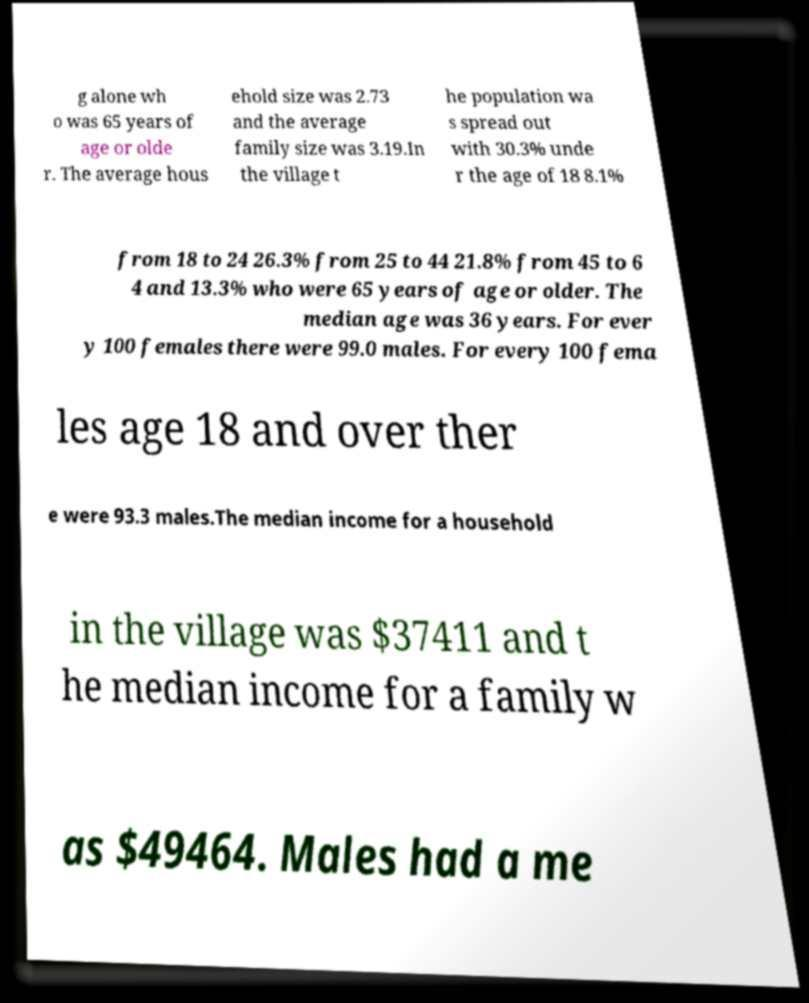I need the written content from this picture converted into text. Can you do that? g alone wh o was 65 years of age or olde r. The average hous ehold size was 2.73 and the average family size was 3.19.In the village t he population wa s spread out with 30.3% unde r the age of 18 8.1% from 18 to 24 26.3% from 25 to 44 21.8% from 45 to 6 4 and 13.3% who were 65 years of age or older. The median age was 36 years. For ever y 100 females there were 99.0 males. For every 100 fema les age 18 and over ther e were 93.3 males.The median income for a household in the village was $37411 and t he median income for a family w as $49464. Males had a me 